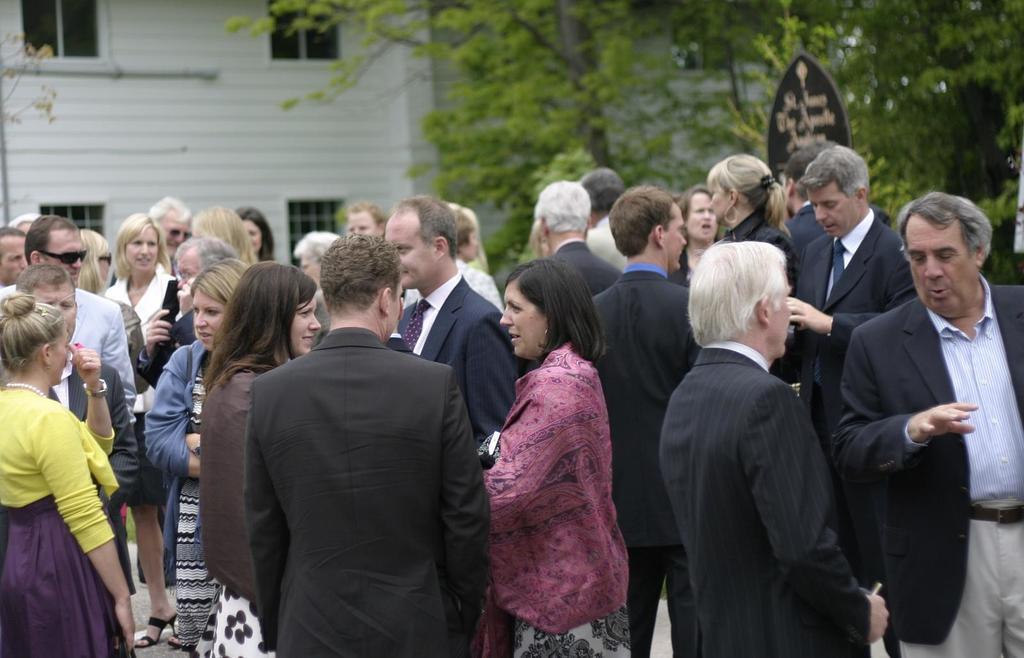How would you summarize this image in a sentence or two? There is a group of people at the bottom of this image. We can see a building and trees in the background. 